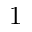<formula> <loc_0><loc_0><loc_500><loc_500>1</formula> 